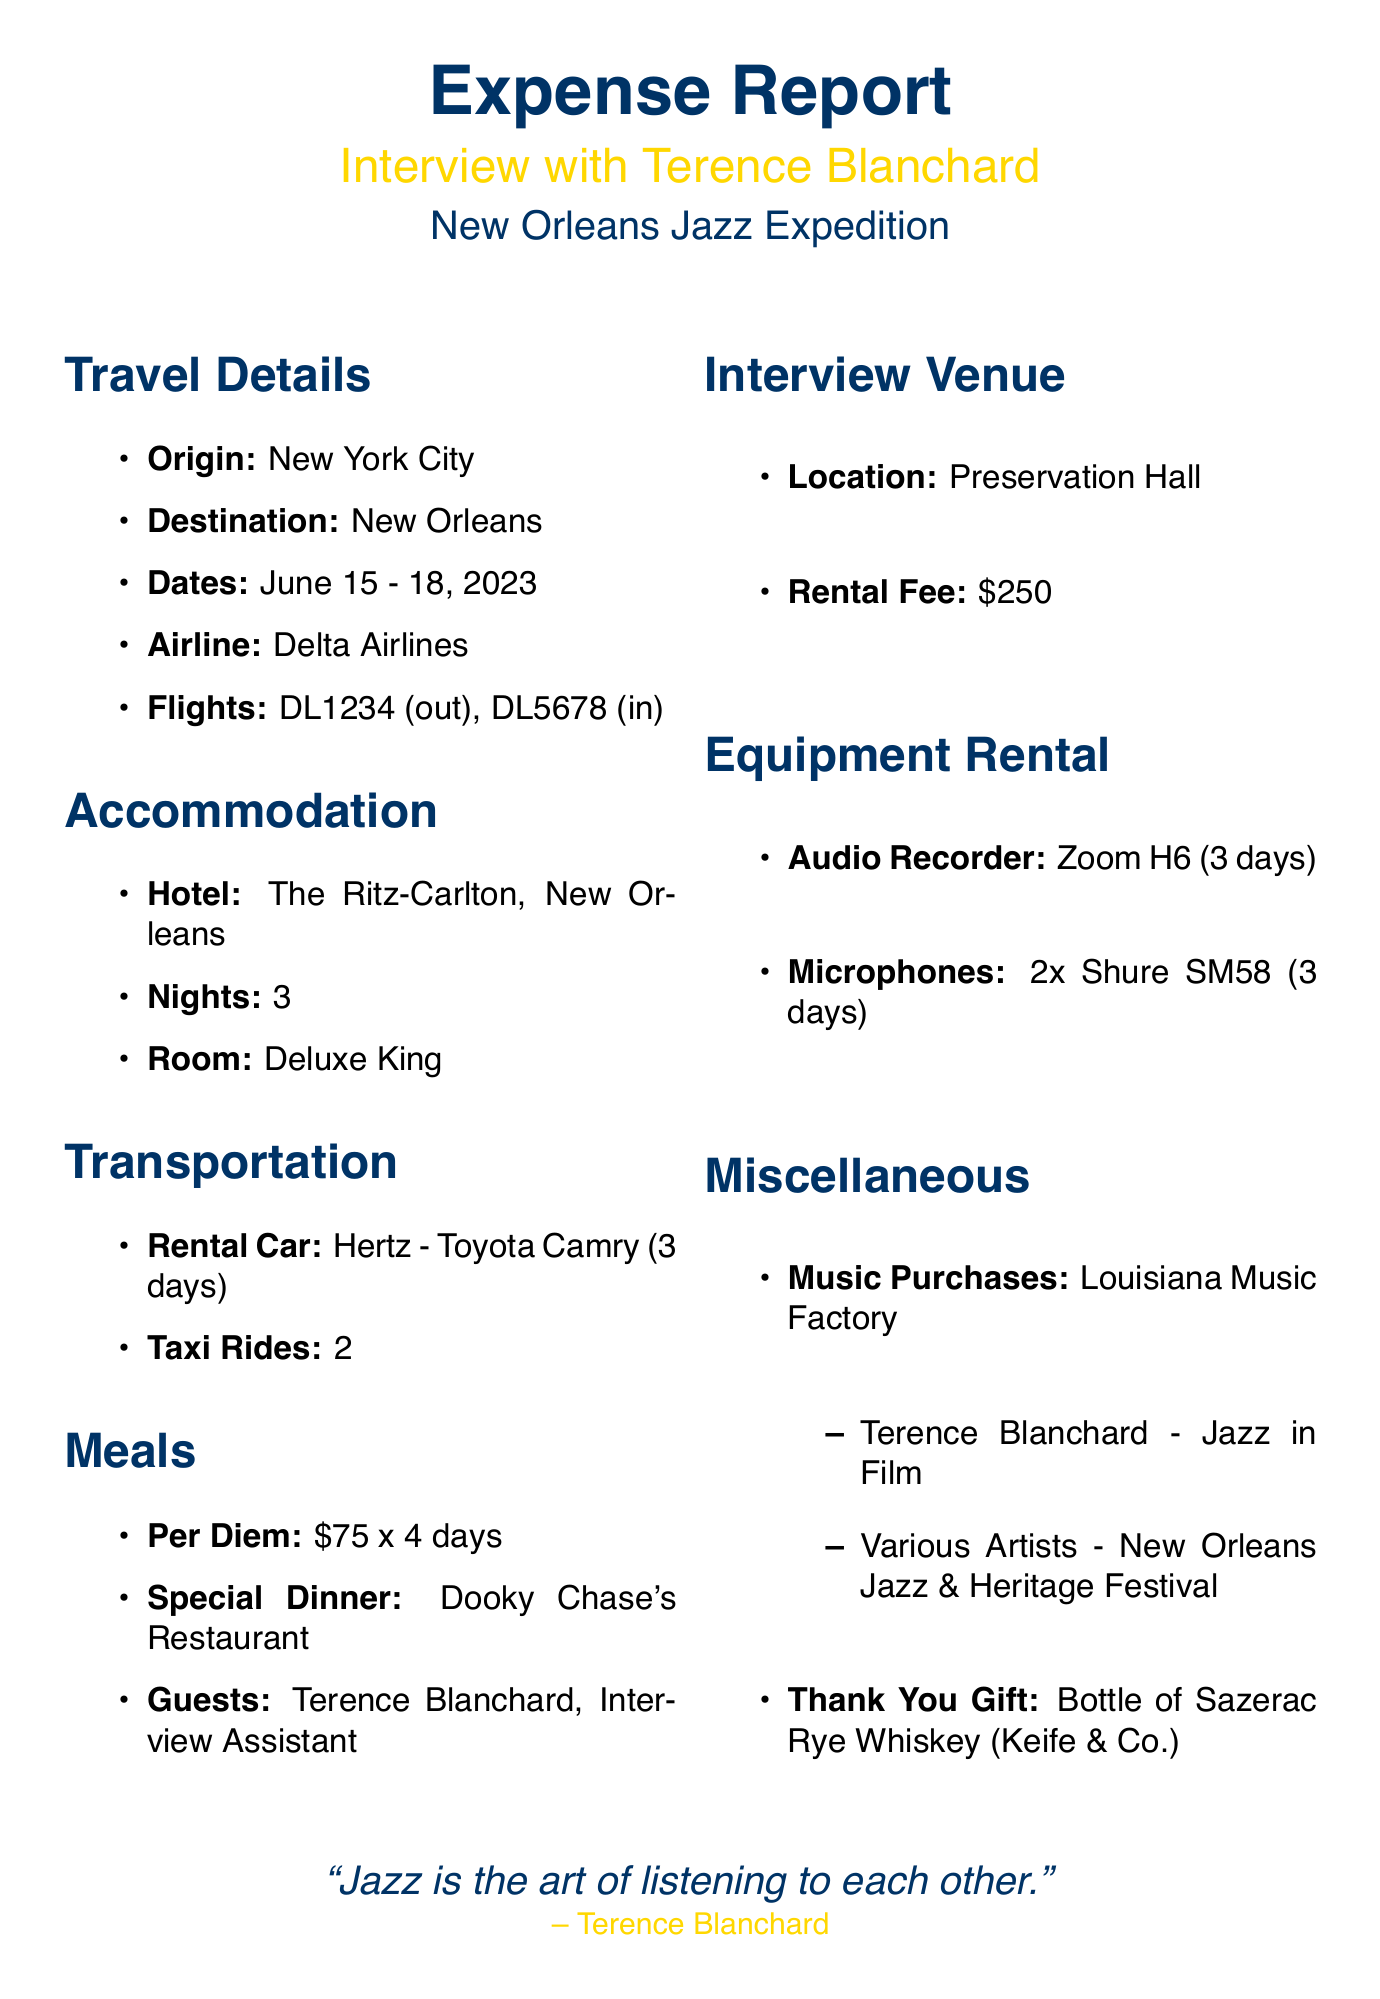What is the name of the interviewee? The document states that the interviewee's name is Terence Blanchard.
Answer: Terence Blanchard What city did the travel originate from? The origin city listed in the document is New York City.
Answer: New York City What hotel was booked for accommodation? The accommodation section of the document specifies The Ritz-Carlton, New Orleans.
Answer: The Ritz-Carlton, New Orleans How many days was the rental car booked for? The document indicates that the rental car was booked for 3 days.
Answer: 3 days What is the per diem amount for meals? According to the meals section, the per diem amount is $75.
Answer: $75 What is the rental fee for the interview venue? The interview venue rental fee listed in the document is $250.
Answer: $250 What restaurant was chosen for the special dinner? The document mentions that the special dinner was at Dooky Chase's Restaurant.
Answer: Dooky Chase's Restaurant How many nights did the stay at the hotel cover? The accommodation section states that the stay at the hotel covered 3 nights.
Answer: 3 nights What items were purchased at the local music store? The miscellaneous section lists two items purchased: Terence Blanchard - Jazz in Film and Various Artists - New Orleans Jazz & Heritage Festival.
Answer: Terence Blanchard - Jazz in Film, Various Artists - New Orleans Jazz & Heritage Festival 